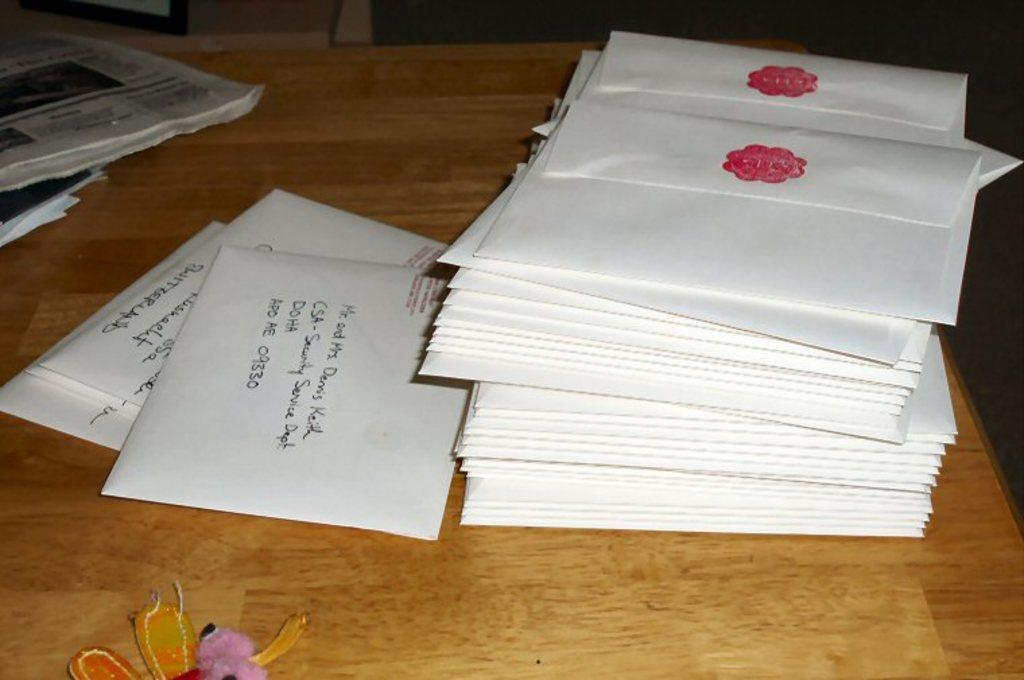Provide a one-sentence caption for the provided image. envelopes on a desk with one addressed to Mr and Mrs Dennis Keith. 